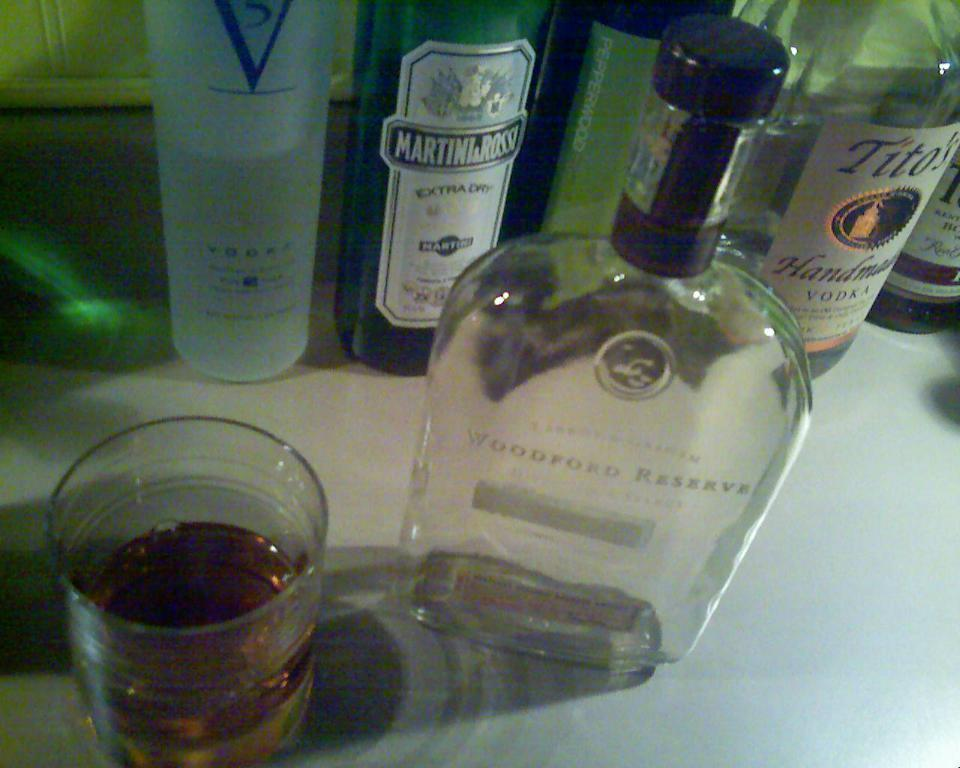What piece of furniture is present in the image? There is a table in the image. What items are on the table? There are bottles and glasses on the table. What is inside the bottles? The bottles contain liquid. What is inside the glasses? The glasses contain liquid. How many clovers can be seen growing on the table in the image? There are no clovers present in the image. 